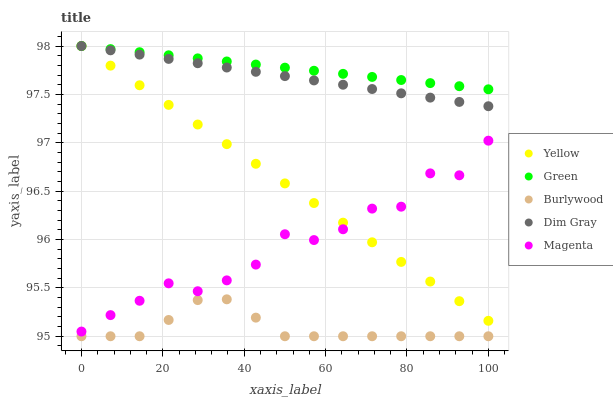Does Burlywood have the minimum area under the curve?
Answer yes or no. Yes. Does Green have the maximum area under the curve?
Answer yes or no. Yes. Does Magenta have the minimum area under the curve?
Answer yes or no. No. Does Magenta have the maximum area under the curve?
Answer yes or no. No. Is Green the smoothest?
Answer yes or no. Yes. Is Magenta the roughest?
Answer yes or no. Yes. Is Dim Gray the smoothest?
Answer yes or no. No. Is Dim Gray the roughest?
Answer yes or no. No. Does Burlywood have the lowest value?
Answer yes or no. Yes. Does Magenta have the lowest value?
Answer yes or no. No. Does Yellow have the highest value?
Answer yes or no. Yes. Does Magenta have the highest value?
Answer yes or no. No. Is Burlywood less than Dim Gray?
Answer yes or no. Yes. Is Green greater than Magenta?
Answer yes or no. Yes. Does Yellow intersect Green?
Answer yes or no. Yes. Is Yellow less than Green?
Answer yes or no. No. Is Yellow greater than Green?
Answer yes or no. No. Does Burlywood intersect Dim Gray?
Answer yes or no. No. 